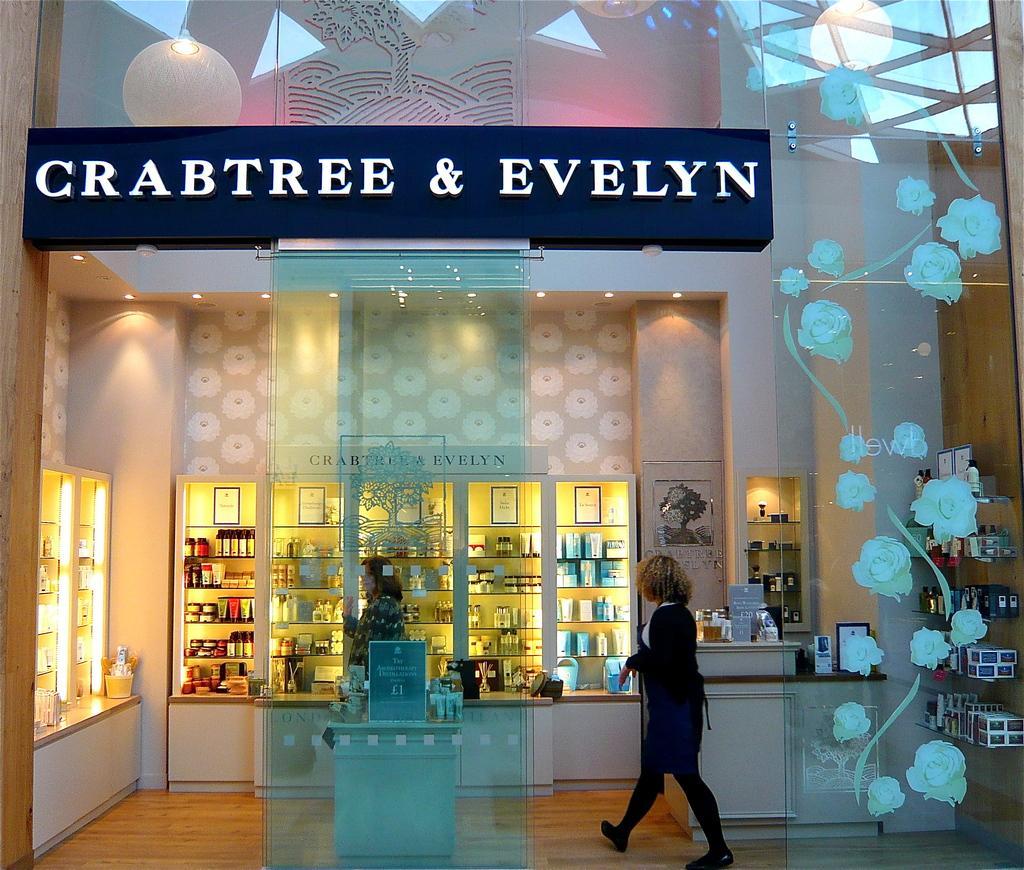In one or two sentences, can you explain what this image depicts? In this image I can see a woman wearing black color dress is standing on the brown colored surface. I can see few glass doors with cream colored design on them. I can see few racks with few bottles in them, a blue colored board, few cream colored walls and few boxes in the racks. 